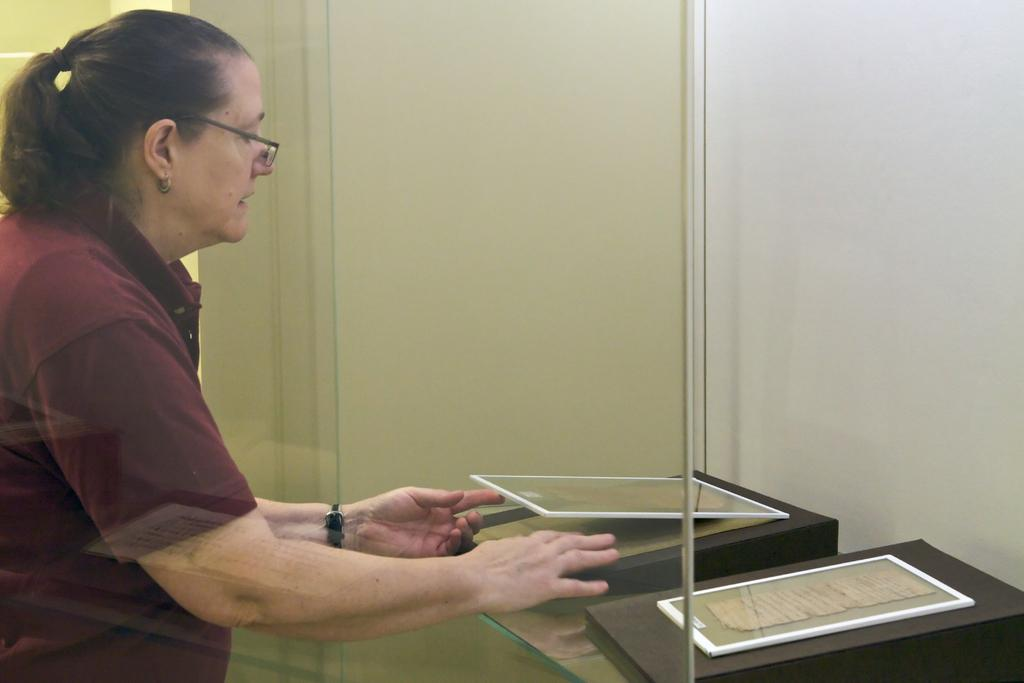What object is present in the image that can hold a liquid? There is a glass in the image. Who is standing behind the glass in the image? A woman is standing behind the glass in the image. What is the woman holding in the image? The woman is holding a frame in the image. How many frames can be seen in the image? There are frames visible in the image. What type of background is present in the image? There is a wall in the image. Can you see a boat in the image? No, there is no boat present in the image. What does the woman wish for in the image? There is no indication of the woman making a wish in the image. 